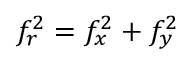Convert formula to latex. <formula><loc_0><loc_0><loc_500><loc_500>f _ { r } ^ { 2 } = f _ { x } ^ { 2 } + f _ { y } ^ { 2 }</formula> 